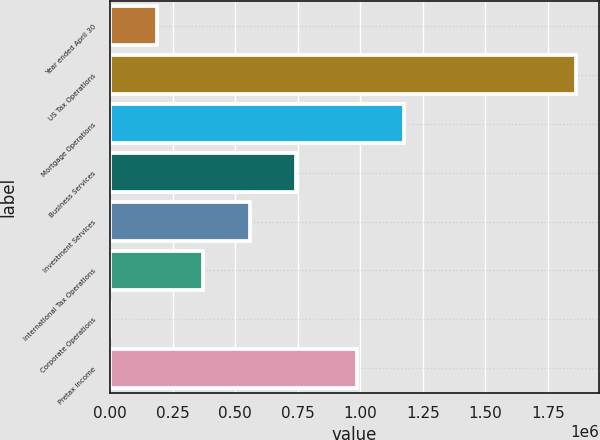Convert chart to OTSL. <chart><loc_0><loc_0><loc_500><loc_500><bar_chart><fcel>Year ended April 30<fcel>US Tax Operations<fcel>Mortgage Operations<fcel>Business Services<fcel>Investment Services<fcel>International Tax Operations<fcel>Corporate Operations<fcel>Pretax income<nl><fcel>186754<fcel>1.86168e+06<fcel>1.17318e+06<fcel>745063<fcel>558960<fcel>372857<fcel>651<fcel>987077<nl></chart> 